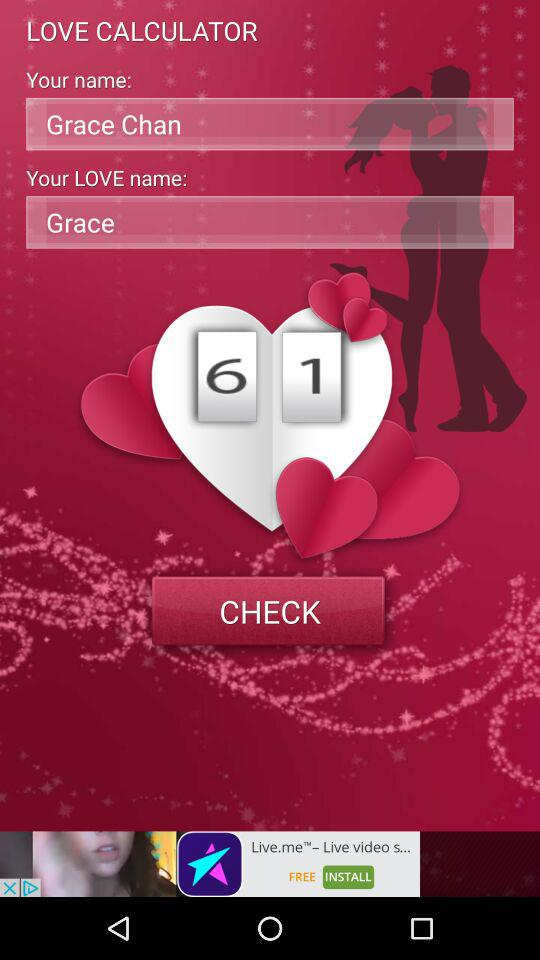What is the love percentage? The love percentage is 61. 